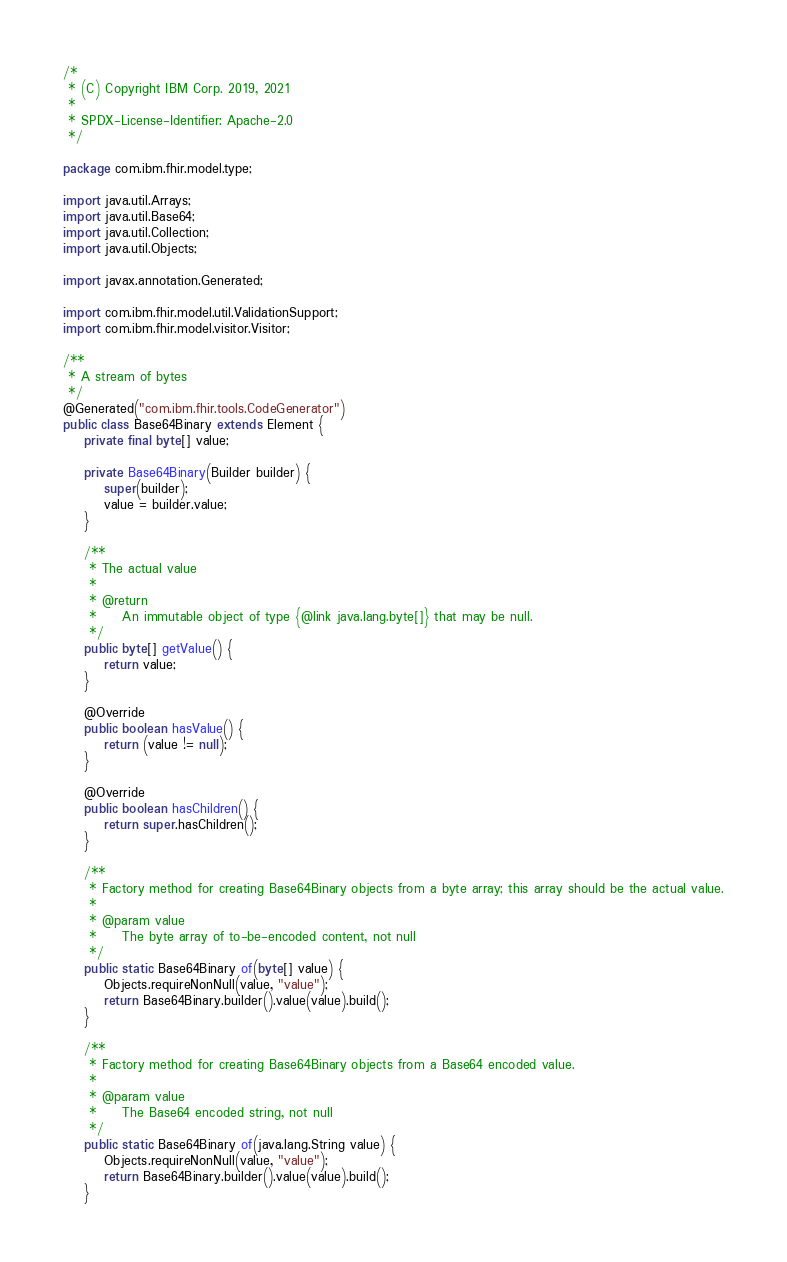<code> <loc_0><loc_0><loc_500><loc_500><_Java_>/*
 * (C) Copyright IBM Corp. 2019, 2021
 *
 * SPDX-License-Identifier: Apache-2.0
 */

package com.ibm.fhir.model.type;

import java.util.Arrays;
import java.util.Base64;
import java.util.Collection;
import java.util.Objects;

import javax.annotation.Generated;

import com.ibm.fhir.model.util.ValidationSupport;
import com.ibm.fhir.model.visitor.Visitor;

/**
 * A stream of bytes
 */
@Generated("com.ibm.fhir.tools.CodeGenerator")
public class Base64Binary extends Element {
    private final byte[] value;

    private Base64Binary(Builder builder) {
        super(builder);
        value = builder.value;
    }

    /**
     * The actual value
     * 
     * @return
     *     An immutable object of type {@link java.lang.byte[]} that may be null.
     */
    public byte[] getValue() {
        return value;
    }

    @Override
    public boolean hasValue() {
        return (value != null);
    }

    @Override
    public boolean hasChildren() {
        return super.hasChildren();
    }

    /**
     * Factory method for creating Base64Binary objects from a byte array; this array should be the actual value.
     * 
     * @param value
     *     The byte array of to-be-encoded content, not null
     */
    public static Base64Binary of(byte[] value) {
        Objects.requireNonNull(value, "value");
        return Base64Binary.builder().value(value).build();
    }

    /**
     * Factory method for creating Base64Binary objects from a Base64 encoded value.
     * 
     * @param value
     *     The Base64 encoded string, not null
     */
    public static Base64Binary of(java.lang.String value) {
        Objects.requireNonNull(value, "value");
        return Base64Binary.builder().value(value).build();
    }
</code> 